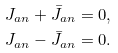Convert formula to latex. <formula><loc_0><loc_0><loc_500><loc_500>J _ { a n } + \bar { J } _ { a n } & = 0 , \\ J _ { a n } - \bar { J } _ { a n } & = 0 .</formula> 